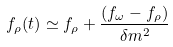<formula> <loc_0><loc_0><loc_500><loc_500>f _ { \rho } ( t ) \simeq f _ { \rho } + \frac { ( f _ { \omega } - f _ { \rho } ) } { \delta m ^ { 2 } }</formula> 